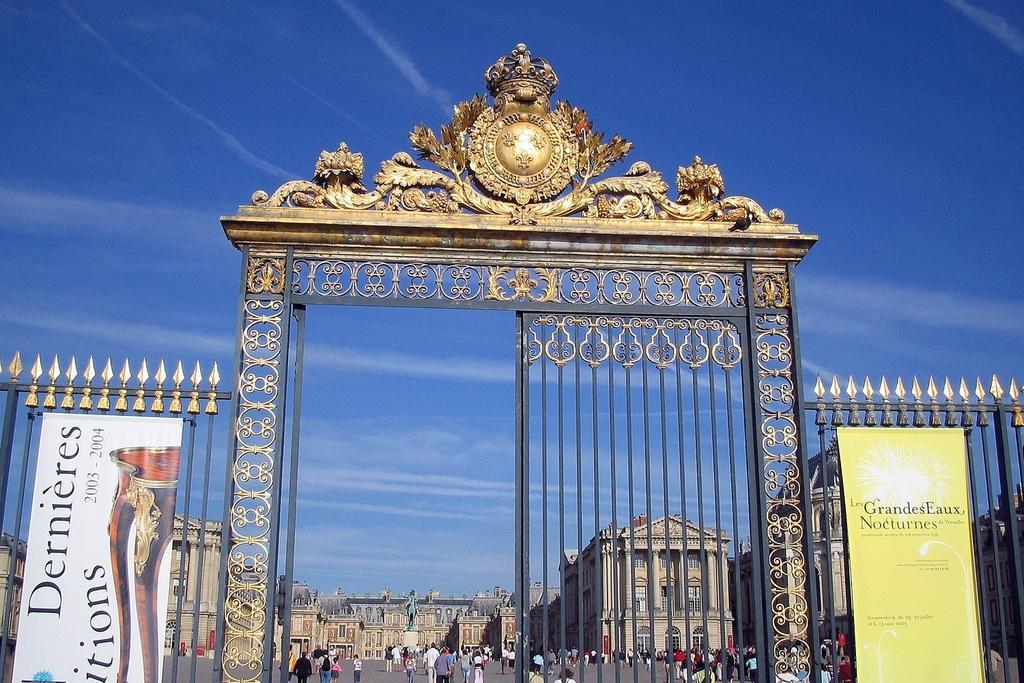Can you describe this image briefly? In the center of the image there is a gate. At the top of the image there is sky. In the background of the image there are buildings. There are people on the road 